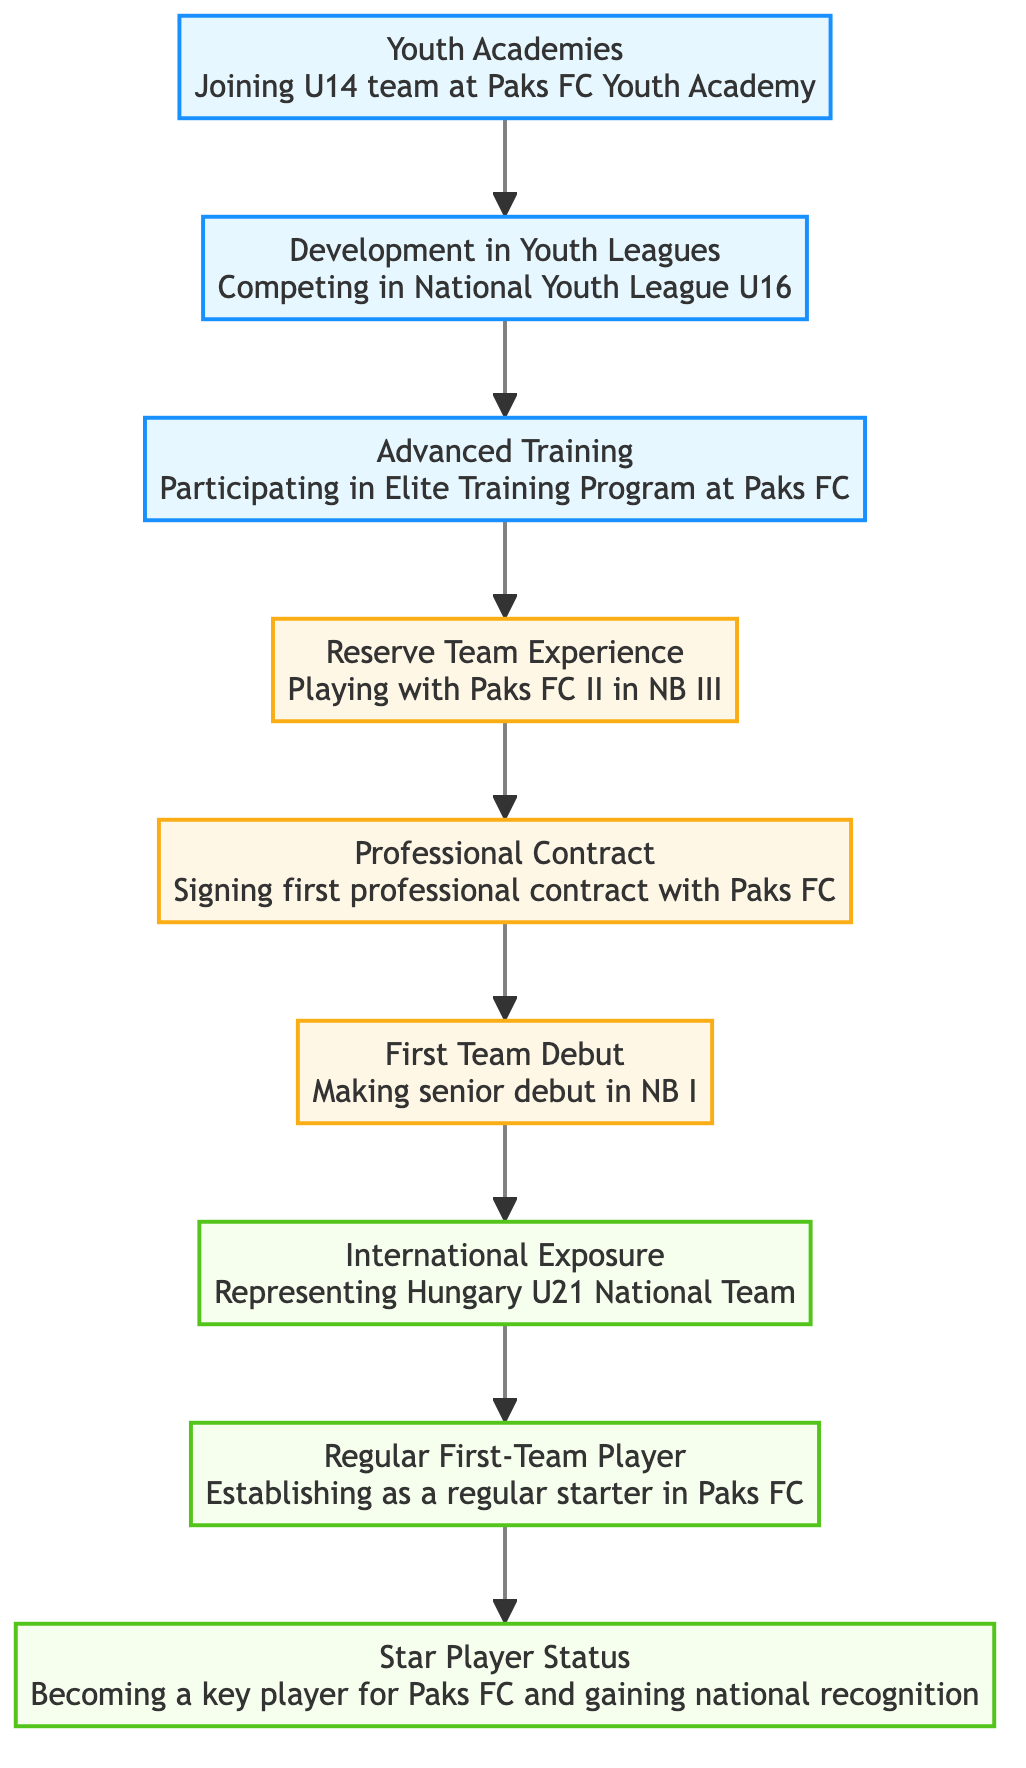What is the highest level in the flow chart? The highest level in the flow chart is represented by the last element, which is "Star Player Status," indicating the peak of a player's career at Paks FC.
Answer: Star Player Status How many nodes are present in the diagram? By counting all the distinct stages from Youth Academies to Star Player Status, there are a total of 9 nodes in the flow chart.
Answer: 9 What is the first step in the player's career path? The flow chart indicates that the first step a player takes on their journey is joining the U14 team at Paks FC Youth Academy.
Answer: Youth Academies Which level comes directly after "Reserve Team Experience"? Following the "Reserve Team Experience," the next level in the progression is "Professional Contract," indicating the transition to a professional player.
Answer: Professional Contract What does the player achieve after making their first team debut? After making their senior debut, the player goes on to represent Hungary U21 National Team, marking an important step in their career for international recognition.
Answer: International Exposure How many levels are there before a player becomes a regular first-team player? Before a player establishes themselves as a regular starter, there are a total of 6 levels to progress through, starting from Youth Academies up to First Team Debut.
Answer: 6 At which level does a player sign their first professional contract? According to the diagram, a player signs their first professional contract at the level labeled "Professional Contract."
Answer: Professional Contract What is the relationship between "First Team Debut" and "Regular First-Team Player"? The flow indicates that after making the First Team Debut, the player moves on to establish themselves as a regular starter in the team, showing a direct progression between these two statuses.
Answer: Progression Which node indicates participation in a training program? The node labeled "Advanced Training" signifies the participation in the Elite Training Program at Paks FC, highlighting an important step in skill development.
Answer: Advanced Training 